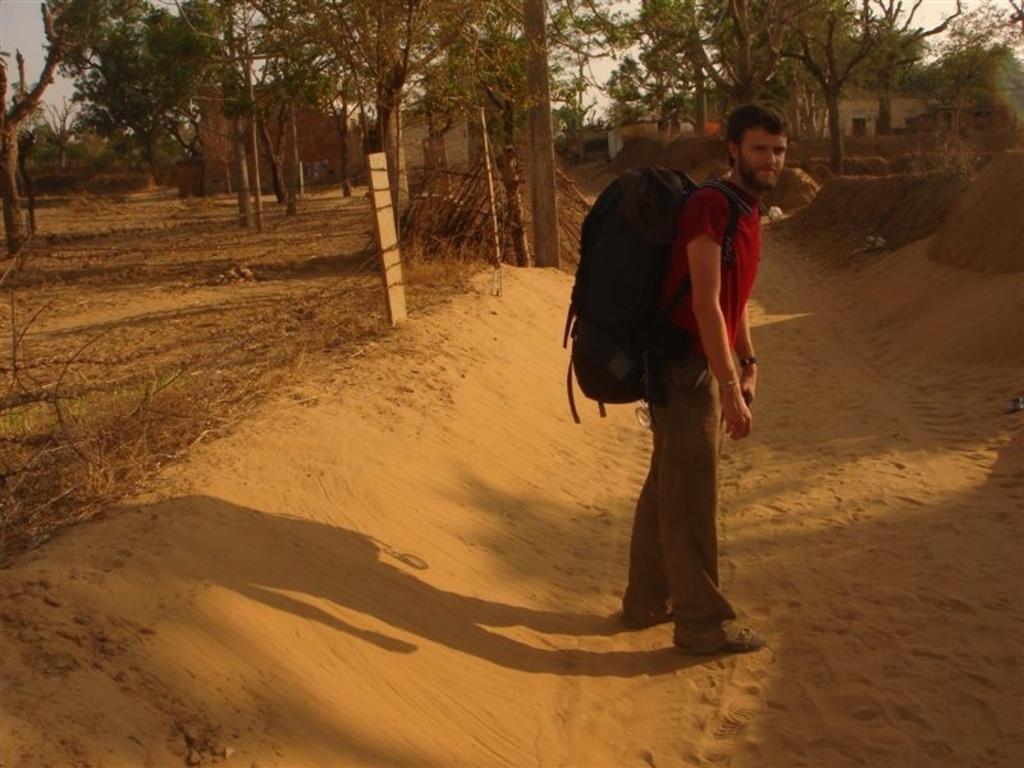Can you describe this image briefly? This is an outside view. Here I can see a man wearing a bag, standing on the ground facing towards the right side. On the left side there is a net fencing. In the background there are many trees and few houses. At the top of the image I can see the sky. 